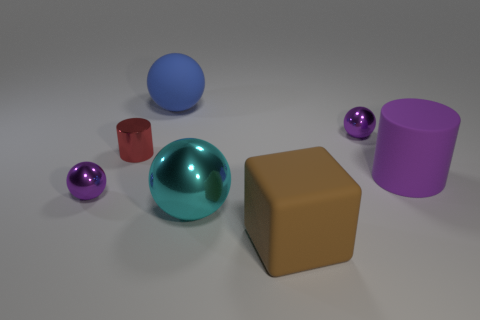Add 3 tiny gray things. How many objects exist? 10 Subtract all gray rubber objects. Subtract all large blue rubber balls. How many objects are left? 6 Add 1 large blue spheres. How many large blue spheres are left? 2 Add 4 big brown matte objects. How many big brown matte objects exist? 5 Subtract all purple balls. How many balls are left? 2 Subtract all cyan metal balls. How many balls are left? 3 Subtract 0 red balls. How many objects are left? 7 Subtract all spheres. How many objects are left? 3 Subtract 2 cylinders. How many cylinders are left? 0 Subtract all blue cylinders. Subtract all brown blocks. How many cylinders are left? 2 